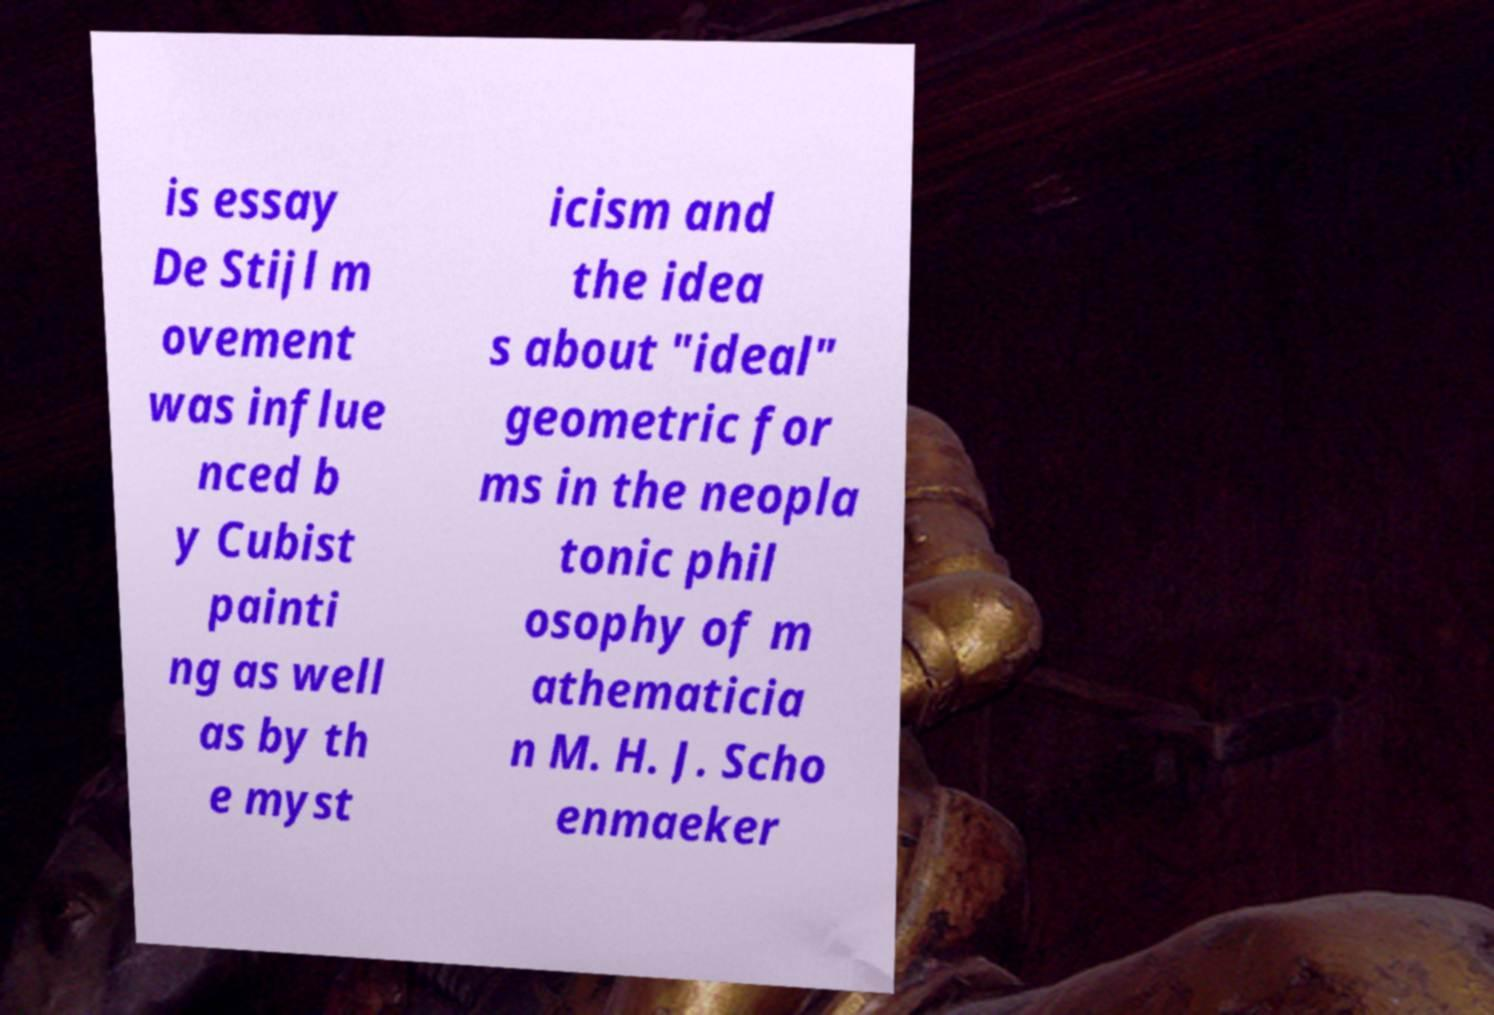Could you assist in decoding the text presented in this image and type it out clearly? is essay De Stijl m ovement was influe nced b y Cubist painti ng as well as by th e myst icism and the idea s about "ideal" geometric for ms in the neopla tonic phil osophy of m athematicia n M. H. J. Scho enmaeker 